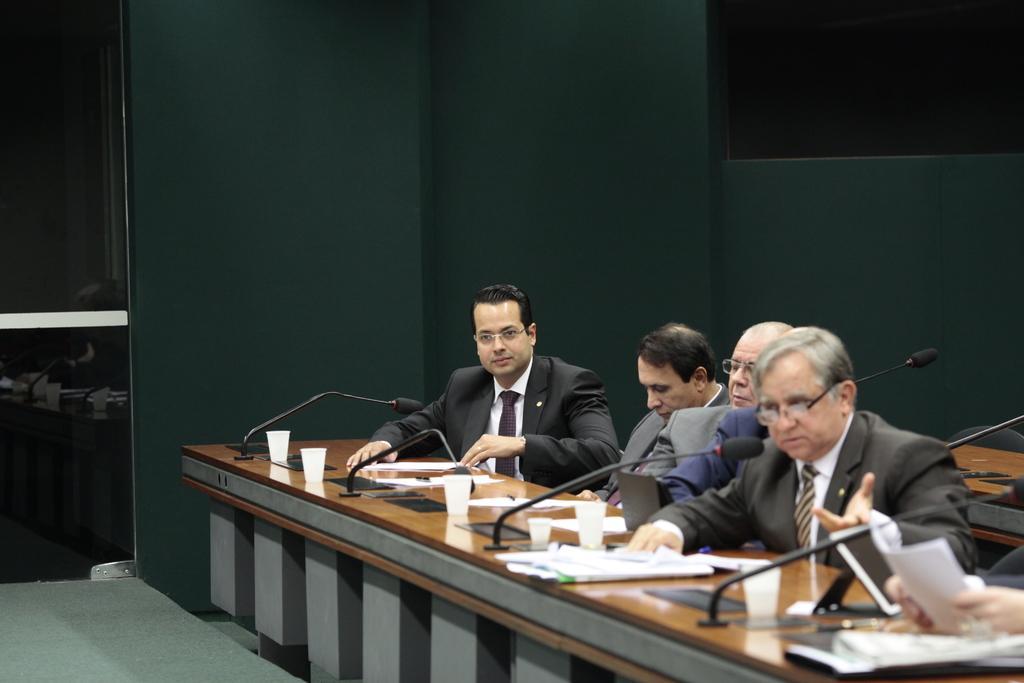Can you describe this image briefly? In the center of the image we can see a table. On the table we can see the mics, cups, papers, screen, books. Beside that we can see some persons are sitting on the chairs. In the background of the image we can see the wall, door, table, chair. At the bottom of the image we can see the floor. 